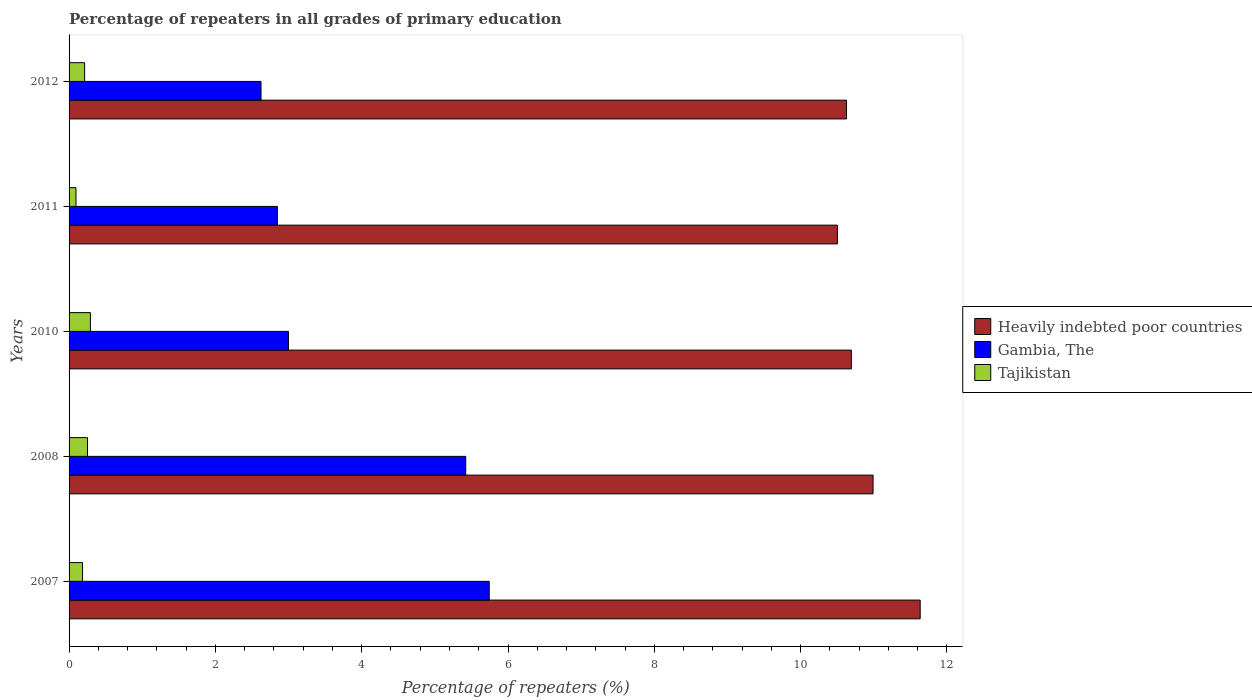How many different coloured bars are there?
Provide a short and direct response. 3. How many bars are there on the 2nd tick from the bottom?
Your answer should be compact. 3. What is the label of the 4th group of bars from the top?
Your response must be concise. 2008. What is the percentage of repeaters in Heavily indebted poor countries in 2011?
Offer a very short reply. 10.5. Across all years, what is the maximum percentage of repeaters in Gambia, The?
Make the answer very short. 5.74. Across all years, what is the minimum percentage of repeaters in Heavily indebted poor countries?
Give a very brief answer. 10.5. In which year was the percentage of repeaters in Heavily indebted poor countries maximum?
Provide a succinct answer. 2007. In which year was the percentage of repeaters in Heavily indebted poor countries minimum?
Your answer should be very brief. 2011. What is the total percentage of repeaters in Gambia, The in the graph?
Offer a terse response. 19.64. What is the difference between the percentage of repeaters in Heavily indebted poor countries in 2007 and that in 2010?
Keep it short and to the point. 0.94. What is the difference between the percentage of repeaters in Heavily indebted poor countries in 2010 and the percentage of repeaters in Tajikistan in 2007?
Provide a succinct answer. 10.51. What is the average percentage of repeaters in Tajikistan per year?
Provide a short and direct response. 0.21. In the year 2008, what is the difference between the percentage of repeaters in Tajikistan and percentage of repeaters in Gambia, The?
Offer a very short reply. -5.17. In how many years, is the percentage of repeaters in Heavily indebted poor countries greater than 1.2000000000000002 %?
Give a very brief answer. 5. What is the ratio of the percentage of repeaters in Gambia, The in 2007 to that in 2008?
Offer a very short reply. 1.06. Is the percentage of repeaters in Gambia, The in 2007 less than that in 2010?
Ensure brevity in your answer.  No. Is the difference between the percentage of repeaters in Tajikistan in 2007 and 2010 greater than the difference between the percentage of repeaters in Gambia, The in 2007 and 2010?
Offer a very short reply. No. What is the difference between the highest and the second highest percentage of repeaters in Gambia, The?
Your answer should be compact. 0.32. What is the difference between the highest and the lowest percentage of repeaters in Gambia, The?
Your answer should be compact. 3.12. In how many years, is the percentage of repeaters in Gambia, The greater than the average percentage of repeaters in Gambia, The taken over all years?
Offer a very short reply. 2. Is the sum of the percentage of repeaters in Tajikistan in 2007 and 2008 greater than the maximum percentage of repeaters in Heavily indebted poor countries across all years?
Keep it short and to the point. No. What does the 2nd bar from the top in 2010 represents?
Give a very brief answer. Gambia, The. What does the 3rd bar from the bottom in 2012 represents?
Give a very brief answer. Tajikistan. How many bars are there?
Provide a short and direct response. 15. Are the values on the major ticks of X-axis written in scientific E-notation?
Provide a short and direct response. No. Does the graph contain any zero values?
Keep it short and to the point. No. Does the graph contain grids?
Provide a succinct answer. No. How are the legend labels stacked?
Offer a terse response. Vertical. What is the title of the graph?
Ensure brevity in your answer.  Percentage of repeaters in all grades of primary education. What is the label or title of the X-axis?
Make the answer very short. Percentage of repeaters (%). What is the label or title of the Y-axis?
Offer a terse response. Years. What is the Percentage of repeaters (%) of Heavily indebted poor countries in 2007?
Ensure brevity in your answer.  11.63. What is the Percentage of repeaters (%) of Gambia, The in 2007?
Your answer should be compact. 5.74. What is the Percentage of repeaters (%) in Tajikistan in 2007?
Your answer should be very brief. 0.18. What is the Percentage of repeaters (%) of Heavily indebted poor countries in 2008?
Keep it short and to the point. 10.99. What is the Percentage of repeaters (%) in Gambia, The in 2008?
Your answer should be very brief. 5.42. What is the Percentage of repeaters (%) of Tajikistan in 2008?
Offer a very short reply. 0.25. What is the Percentage of repeaters (%) of Heavily indebted poor countries in 2010?
Your answer should be very brief. 10.69. What is the Percentage of repeaters (%) of Gambia, The in 2010?
Ensure brevity in your answer.  3. What is the Percentage of repeaters (%) in Tajikistan in 2010?
Your response must be concise. 0.29. What is the Percentage of repeaters (%) in Heavily indebted poor countries in 2011?
Offer a very short reply. 10.5. What is the Percentage of repeaters (%) in Gambia, The in 2011?
Offer a very short reply. 2.85. What is the Percentage of repeaters (%) in Tajikistan in 2011?
Ensure brevity in your answer.  0.09. What is the Percentage of repeaters (%) in Heavily indebted poor countries in 2012?
Provide a succinct answer. 10.63. What is the Percentage of repeaters (%) of Gambia, The in 2012?
Your answer should be compact. 2.62. What is the Percentage of repeaters (%) of Tajikistan in 2012?
Give a very brief answer. 0.21. Across all years, what is the maximum Percentage of repeaters (%) of Heavily indebted poor countries?
Offer a very short reply. 11.63. Across all years, what is the maximum Percentage of repeaters (%) in Gambia, The?
Keep it short and to the point. 5.74. Across all years, what is the maximum Percentage of repeaters (%) in Tajikistan?
Make the answer very short. 0.29. Across all years, what is the minimum Percentage of repeaters (%) of Heavily indebted poor countries?
Offer a very short reply. 10.5. Across all years, what is the minimum Percentage of repeaters (%) of Gambia, The?
Offer a very short reply. 2.62. Across all years, what is the minimum Percentage of repeaters (%) of Tajikistan?
Offer a terse response. 0.09. What is the total Percentage of repeaters (%) in Heavily indebted poor countries in the graph?
Make the answer very short. 54.45. What is the total Percentage of repeaters (%) in Gambia, The in the graph?
Offer a terse response. 19.64. What is the total Percentage of repeaters (%) in Tajikistan in the graph?
Offer a very short reply. 1.03. What is the difference between the Percentage of repeaters (%) of Heavily indebted poor countries in 2007 and that in 2008?
Your answer should be very brief. 0.64. What is the difference between the Percentage of repeaters (%) in Gambia, The in 2007 and that in 2008?
Provide a short and direct response. 0.32. What is the difference between the Percentage of repeaters (%) of Tajikistan in 2007 and that in 2008?
Offer a terse response. -0.07. What is the difference between the Percentage of repeaters (%) of Heavily indebted poor countries in 2007 and that in 2010?
Make the answer very short. 0.94. What is the difference between the Percentage of repeaters (%) in Gambia, The in 2007 and that in 2010?
Give a very brief answer. 2.74. What is the difference between the Percentage of repeaters (%) of Tajikistan in 2007 and that in 2010?
Give a very brief answer. -0.11. What is the difference between the Percentage of repeaters (%) of Heavily indebted poor countries in 2007 and that in 2011?
Your answer should be very brief. 1.13. What is the difference between the Percentage of repeaters (%) in Gambia, The in 2007 and that in 2011?
Make the answer very short. 2.9. What is the difference between the Percentage of repeaters (%) in Tajikistan in 2007 and that in 2011?
Provide a short and direct response. 0.09. What is the difference between the Percentage of repeaters (%) of Heavily indebted poor countries in 2007 and that in 2012?
Give a very brief answer. 1.01. What is the difference between the Percentage of repeaters (%) in Gambia, The in 2007 and that in 2012?
Your response must be concise. 3.12. What is the difference between the Percentage of repeaters (%) in Tajikistan in 2007 and that in 2012?
Provide a short and direct response. -0.03. What is the difference between the Percentage of repeaters (%) of Heavily indebted poor countries in 2008 and that in 2010?
Provide a short and direct response. 0.3. What is the difference between the Percentage of repeaters (%) of Gambia, The in 2008 and that in 2010?
Your response must be concise. 2.42. What is the difference between the Percentage of repeaters (%) of Tajikistan in 2008 and that in 2010?
Make the answer very short. -0.04. What is the difference between the Percentage of repeaters (%) of Heavily indebted poor countries in 2008 and that in 2011?
Ensure brevity in your answer.  0.49. What is the difference between the Percentage of repeaters (%) of Gambia, The in 2008 and that in 2011?
Offer a very short reply. 2.57. What is the difference between the Percentage of repeaters (%) in Tajikistan in 2008 and that in 2011?
Your answer should be very brief. 0.16. What is the difference between the Percentage of repeaters (%) in Heavily indebted poor countries in 2008 and that in 2012?
Keep it short and to the point. 0.36. What is the difference between the Percentage of repeaters (%) of Gambia, The in 2008 and that in 2012?
Provide a short and direct response. 2.8. What is the difference between the Percentage of repeaters (%) in Tajikistan in 2008 and that in 2012?
Provide a short and direct response. 0.04. What is the difference between the Percentage of repeaters (%) in Heavily indebted poor countries in 2010 and that in 2011?
Offer a very short reply. 0.19. What is the difference between the Percentage of repeaters (%) of Gambia, The in 2010 and that in 2011?
Your answer should be very brief. 0.15. What is the difference between the Percentage of repeaters (%) of Tajikistan in 2010 and that in 2011?
Your response must be concise. 0.2. What is the difference between the Percentage of repeaters (%) of Heavily indebted poor countries in 2010 and that in 2012?
Offer a very short reply. 0.07. What is the difference between the Percentage of repeaters (%) in Gambia, The in 2010 and that in 2012?
Provide a succinct answer. 0.38. What is the difference between the Percentage of repeaters (%) in Tajikistan in 2010 and that in 2012?
Keep it short and to the point. 0.08. What is the difference between the Percentage of repeaters (%) in Heavily indebted poor countries in 2011 and that in 2012?
Keep it short and to the point. -0.12. What is the difference between the Percentage of repeaters (%) of Gambia, The in 2011 and that in 2012?
Provide a succinct answer. 0.22. What is the difference between the Percentage of repeaters (%) of Tajikistan in 2011 and that in 2012?
Provide a short and direct response. -0.12. What is the difference between the Percentage of repeaters (%) in Heavily indebted poor countries in 2007 and the Percentage of repeaters (%) in Gambia, The in 2008?
Your response must be concise. 6.21. What is the difference between the Percentage of repeaters (%) of Heavily indebted poor countries in 2007 and the Percentage of repeaters (%) of Tajikistan in 2008?
Offer a very short reply. 11.38. What is the difference between the Percentage of repeaters (%) of Gambia, The in 2007 and the Percentage of repeaters (%) of Tajikistan in 2008?
Your answer should be compact. 5.49. What is the difference between the Percentage of repeaters (%) in Heavily indebted poor countries in 2007 and the Percentage of repeaters (%) in Gambia, The in 2010?
Give a very brief answer. 8.63. What is the difference between the Percentage of repeaters (%) in Heavily indebted poor countries in 2007 and the Percentage of repeaters (%) in Tajikistan in 2010?
Give a very brief answer. 11.34. What is the difference between the Percentage of repeaters (%) of Gambia, The in 2007 and the Percentage of repeaters (%) of Tajikistan in 2010?
Offer a very short reply. 5.45. What is the difference between the Percentage of repeaters (%) in Heavily indebted poor countries in 2007 and the Percentage of repeaters (%) in Gambia, The in 2011?
Provide a short and direct response. 8.79. What is the difference between the Percentage of repeaters (%) of Heavily indebted poor countries in 2007 and the Percentage of repeaters (%) of Tajikistan in 2011?
Keep it short and to the point. 11.54. What is the difference between the Percentage of repeaters (%) in Gambia, The in 2007 and the Percentage of repeaters (%) in Tajikistan in 2011?
Ensure brevity in your answer.  5.65. What is the difference between the Percentage of repeaters (%) of Heavily indebted poor countries in 2007 and the Percentage of repeaters (%) of Gambia, The in 2012?
Your answer should be very brief. 9.01. What is the difference between the Percentage of repeaters (%) in Heavily indebted poor countries in 2007 and the Percentage of repeaters (%) in Tajikistan in 2012?
Your response must be concise. 11.42. What is the difference between the Percentage of repeaters (%) in Gambia, The in 2007 and the Percentage of repeaters (%) in Tajikistan in 2012?
Provide a short and direct response. 5.53. What is the difference between the Percentage of repeaters (%) in Heavily indebted poor countries in 2008 and the Percentage of repeaters (%) in Gambia, The in 2010?
Offer a very short reply. 7.99. What is the difference between the Percentage of repeaters (%) of Heavily indebted poor countries in 2008 and the Percentage of repeaters (%) of Tajikistan in 2010?
Offer a terse response. 10.7. What is the difference between the Percentage of repeaters (%) of Gambia, The in 2008 and the Percentage of repeaters (%) of Tajikistan in 2010?
Keep it short and to the point. 5.13. What is the difference between the Percentage of repeaters (%) in Heavily indebted poor countries in 2008 and the Percentage of repeaters (%) in Gambia, The in 2011?
Your response must be concise. 8.14. What is the difference between the Percentage of repeaters (%) in Heavily indebted poor countries in 2008 and the Percentage of repeaters (%) in Tajikistan in 2011?
Offer a very short reply. 10.9. What is the difference between the Percentage of repeaters (%) of Gambia, The in 2008 and the Percentage of repeaters (%) of Tajikistan in 2011?
Offer a terse response. 5.33. What is the difference between the Percentage of repeaters (%) in Heavily indebted poor countries in 2008 and the Percentage of repeaters (%) in Gambia, The in 2012?
Provide a succinct answer. 8.37. What is the difference between the Percentage of repeaters (%) of Heavily indebted poor countries in 2008 and the Percentage of repeaters (%) of Tajikistan in 2012?
Give a very brief answer. 10.78. What is the difference between the Percentage of repeaters (%) of Gambia, The in 2008 and the Percentage of repeaters (%) of Tajikistan in 2012?
Provide a succinct answer. 5.21. What is the difference between the Percentage of repeaters (%) in Heavily indebted poor countries in 2010 and the Percentage of repeaters (%) in Gambia, The in 2011?
Your response must be concise. 7.85. What is the difference between the Percentage of repeaters (%) of Heavily indebted poor countries in 2010 and the Percentage of repeaters (%) of Tajikistan in 2011?
Keep it short and to the point. 10.6. What is the difference between the Percentage of repeaters (%) of Gambia, The in 2010 and the Percentage of repeaters (%) of Tajikistan in 2011?
Make the answer very short. 2.9. What is the difference between the Percentage of repeaters (%) of Heavily indebted poor countries in 2010 and the Percentage of repeaters (%) of Gambia, The in 2012?
Your answer should be compact. 8.07. What is the difference between the Percentage of repeaters (%) of Heavily indebted poor countries in 2010 and the Percentage of repeaters (%) of Tajikistan in 2012?
Offer a terse response. 10.48. What is the difference between the Percentage of repeaters (%) in Gambia, The in 2010 and the Percentage of repeaters (%) in Tajikistan in 2012?
Your answer should be compact. 2.79. What is the difference between the Percentage of repeaters (%) in Heavily indebted poor countries in 2011 and the Percentage of repeaters (%) in Gambia, The in 2012?
Keep it short and to the point. 7.88. What is the difference between the Percentage of repeaters (%) in Heavily indebted poor countries in 2011 and the Percentage of repeaters (%) in Tajikistan in 2012?
Keep it short and to the point. 10.29. What is the difference between the Percentage of repeaters (%) in Gambia, The in 2011 and the Percentage of repeaters (%) in Tajikistan in 2012?
Make the answer very short. 2.63. What is the average Percentage of repeaters (%) in Heavily indebted poor countries per year?
Your answer should be compact. 10.89. What is the average Percentage of repeaters (%) in Gambia, The per year?
Your answer should be compact. 3.93. What is the average Percentage of repeaters (%) in Tajikistan per year?
Give a very brief answer. 0.21. In the year 2007, what is the difference between the Percentage of repeaters (%) in Heavily indebted poor countries and Percentage of repeaters (%) in Gambia, The?
Give a very brief answer. 5.89. In the year 2007, what is the difference between the Percentage of repeaters (%) in Heavily indebted poor countries and Percentage of repeaters (%) in Tajikistan?
Offer a terse response. 11.45. In the year 2007, what is the difference between the Percentage of repeaters (%) of Gambia, The and Percentage of repeaters (%) of Tajikistan?
Offer a terse response. 5.56. In the year 2008, what is the difference between the Percentage of repeaters (%) of Heavily indebted poor countries and Percentage of repeaters (%) of Gambia, The?
Your answer should be compact. 5.57. In the year 2008, what is the difference between the Percentage of repeaters (%) in Heavily indebted poor countries and Percentage of repeaters (%) in Tajikistan?
Make the answer very short. 10.74. In the year 2008, what is the difference between the Percentage of repeaters (%) of Gambia, The and Percentage of repeaters (%) of Tajikistan?
Your response must be concise. 5.17. In the year 2010, what is the difference between the Percentage of repeaters (%) of Heavily indebted poor countries and Percentage of repeaters (%) of Gambia, The?
Provide a succinct answer. 7.69. In the year 2010, what is the difference between the Percentage of repeaters (%) in Heavily indebted poor countries and Percentage of repeaters (%) in Tajikistan?
Your response must be concise. 10.4. In the year 2010, what is the difference between the Percentage of repeaters (%) in Gambia, The and Percentage of repeaters (%) in Tajikistan?
Your response must be concise. 2.71. In the year 2011, what is the difference between the Percentage of repeaters (%) in Heavily indebted poor countries and Percentage of repeaters (%) in Gambia, The?
Ensure brevity in your answer.  7.66. In the year 2011, what is the difference between the Percentage of repeaters (%) of Heavily indebted poor countries and Percentage of repeaters (%) of Tajikistan?
Provide a succinct answer. 10.41. In the year 2011, what is the difference between the Percentage of repeaters (%) in Gambia, The and Percentage of repeaters (%) in Tajikistan?
Ensure brevity in your answer.  2.75. In the year 2012, what is the difference between the Percentage of repeaters (%) in Heavily indebted poor countries and Percentage of repeaters (%) in Gambia, The?
Provide a short and direct response. 8. In the year 2012, what is the difference between the Percentage of repeaters (%) of Heavily indebted poor countries and Percentage of repeaters (%) of Tajikistan?
Give a very brief answer. 10.41. In the year 2012, what is the difference between the Percentage of repeaters (%) in Gambia, The and Percentage of repeaters (%) in Tajikistan?
Offer a terse response. 2.41. What is the ratio of the Percentage of repeaters (%) of Heavily indebted poor countries in 2007 to that in 2008?
Your answer should be very brief. 1.06. What is the ratio of the Percentage of repeaters (%) in Gambia, The in 2007 to that in 2008?
Ensure brevity in your answer.  1.06. What is the ratio of the Percentage of repeaters (%) of Tajikistan in 2007 to that in 2008?
Your answer should be very brief. 0.73. What is the ratio of the Percentage of repeaters (%) of Heavily indebted poor countries in 2007 to that in 2010?
Your answer should be very brief. 1.09. What is the ratio of the Percentage of repeaters (%) of Gambia, The in 2007 to that in 2010?
Provide a succinct answer. 1.91. What is the ratio of the Percentage of repeaters (%) of Tajikistan in 2007 to that in 2010?
Provide a short and direct response. 0.63. What is the ratio of the Percentage of repeaters (%) in Heavily indebted poor countries in 2007 to that in 2011?
Ensure brevity in your answer.  1.11. What is the ratio of the Percentage of repeaters (%) in Gambia, The in 2007 to that in 2011?
Keep it short and to the point. 2.02. What is the ratio of the Percentage of repeaters (%) in Tajikistan in 2007 to that in 2011?
Your response must be concise. 1.95. What is the ratio of the Percentage of repeaters (%) of Heavily indebted poor countries in 2007 to that in 2012?
Keep it short and to the point. 1.09. What is the ratio of the Percentage of repeaters (%) of Gambia, The in 2007 to that in 2012?
Give a very brief answer. 2.19. What is the ratio of the Percentage of repeaters (%) of Tajikistan in 2007 to that in 2012?
Keep it short and to the point. 0.87. What is the ratio of the Percentage of repeaters (%) of Heavily indebted poor countries in 2008 to that in 2010?
Offer a terse response. 1.03. What is the ratio of the Percentage of repeaters (%) of Gambia, The in 2008 to that in 2010?
Your response must be concise. 1.81. What is the ratio of the Percentage of repeaters (%) in Tajikistan in 2008 to that in 2010?
Your response must be concise. 0.86. What is the ratio of the Percentage of repeaters (%) of Heavily indebted poor countries in 2008 to that in 2011?
Provide a short and direct response. 1.05. What is the ratio of the Percentage of repeaters (%) of Gambia, The in 2008 to that in 2011?
Offer a very short reply. 1.9. What is the ratio of the Percentage of repeaters (%) in Tajikistan in 2008 to that in 2011?
Your response must be concise. 2.66. What is the ratio of the Percentage of repeaters (%) in Heavily indebted poor countries in 2008 to that in 2012?
Ensure brevity in your answer.  1.03. What is the ratio of the Percentage of repeaters (%) in Gambia, The in 2008 to that in 2012?
Your response must be concise. 2.07. What is the ratio of the Percentage of repeaters (%) of Tajikistan in 2008 to that in 2012?
Provide a short and direct response. 1.18. What is the ratio of the Percentage of repeaters (%) of Heavily indebted poor countries in 2010 to that in 2011?
Your answer should be compact. 1.02. What is the ratio of the Percentage of repeaters (%) in Gambia, The in 2010 to that in 2011?
Provide a succinct answer. 1.05. What is the ratio of the Percentage of repeaters (%) of Tajikistan in 2010 to that in 2011?
Make the answer very short. 3.09. What is the ratio of the Percentage of repeaters (%) in Gambia, The in 2010 to that in 2012?
Ensure brevity in your answer.  1.14. What is the ratio of the Percentage of repeaters (%) in Tajikistan in 2010 to that in 2012?
Your answer should be very brief. 1.37. What is the ratio of the Percentage of repeaters (%) of Heavily indebted poor countries in 2011 to that in 2012?
Keep it short and to the point. 0.99. What is the ratio of the Percentage of repeaters (%) in Gambia, The in 2011 to that in 2012?
Make the answer very short. 1.09. What is the ratio of the Percentage of repeaters (%) in Tajikistan in 2011 to that in 2012?
Make the answer very short. 0.44. What is the difference between the highest and the second highest Percentage of repeaters (%) of Heavily indebted poor countries?
Your answer should be very brief. 0.64. What is the difference between the highest and the second highest Percentage of repeaters (%) of Gambia, The?
Ensure brevity in your answer.  0.32. What is the difference between the highest and the second highest Percentage of repeaters (%) in Tajikistan?
Provide a short and direct response. 0.04. What is the difference between the highest and the lowest Percentage of repeaters (%) of Heavily indebted poor countries?
Give a very brief answer. 1.13. What is the difference between the highest and the lowest Percentage of repeaters (%) of Gambia, The?
Offer a terse response. 3.12. What is the difference between the highest and the lowest Percentage of repeaters (%) in Tajikistan?
Your response must be concise. 0.2. 